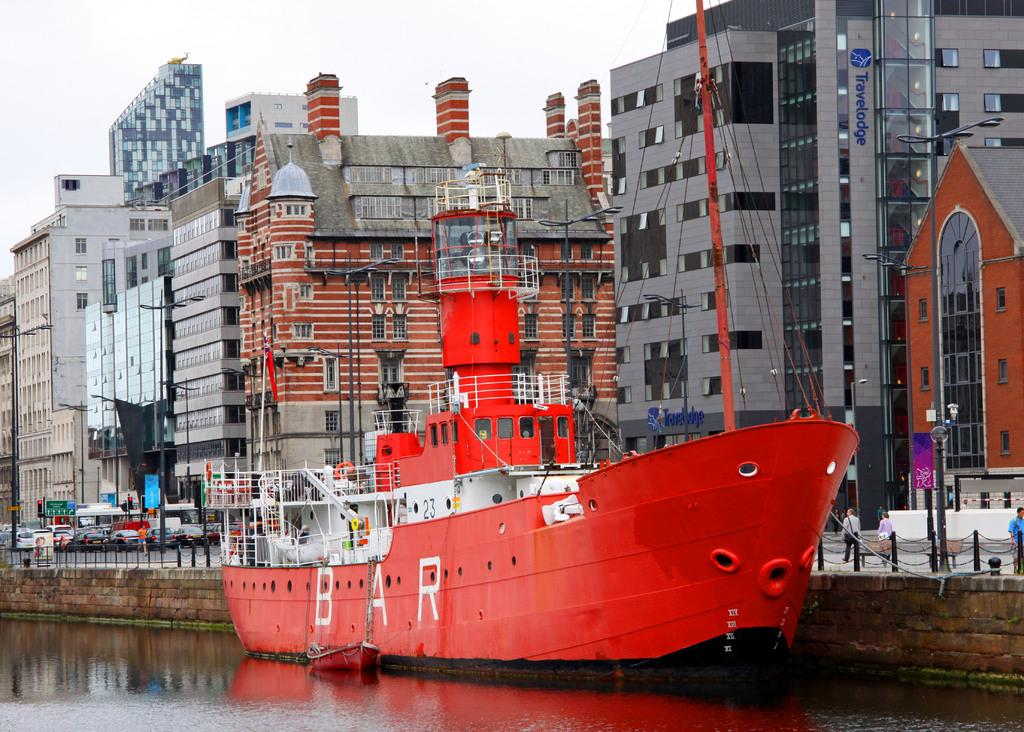What type of structures can be seen in the image? There are buildings in the image. What activity are the cars engaged in near the traffic signal? The cars are waiting near a traffic signal. What are the people at the bottom of the image doing? There are people walking at the bottom of the image. Can you see any sea creatures swimming near the buildings in the image? There is no sea or sea creatures present in the image; it features buildings, cars, and people. What type of bone is visible in the hands of the people walking at the bottom of the image? There is no bone present in the image; the people walking are not holding any bones. 